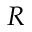Convert formula to latex. <formula><loc_0><loc_0><loc_500><loc_500>R</formula> 